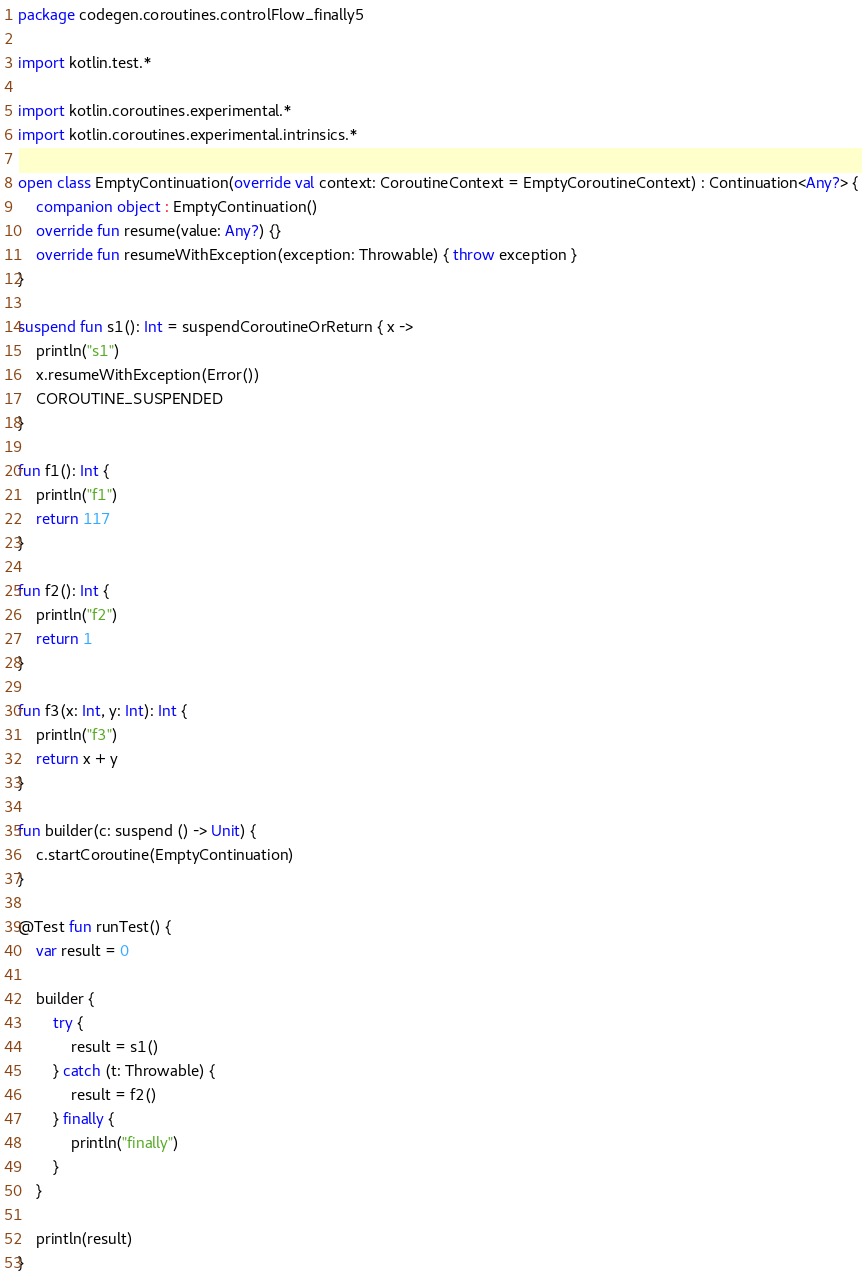<code> <loc_0><loc_0><loc_500><loc_500><_Kotlin_>package codegen.coroutines.controlFlow_finally5

import kotlin.test.*

import kotlin.coroutines.experimental.*
import kotlin.coroutines.experimental.intrinsics.*

open class EmptyContinuation(override val context: CoroutineContext = EmptyCoroutineContext) : Continuation<Any?> {
    companion object : EmptyContinuation()
    override fun resume(value: Any?) {}
    override fun resumeWithException(exception: Throwable) { throw exception }
}

suspend fun s1(): Int = suspendCoroutineOrReturn { x ->
    println("s1")
    x.resumeWithException(Error())
    COROUTINE_SUSPENDED
}

fun f1(): Int {
    println("f1")
    return 117
}

fun f2(): Int {
    println("f2")
    return 1
}

fun f3(x: Int, y: Int): Int {
    println("f3")
    return x + y
}

fun builder(c: suspend () -> Unit) {
    c.startCoroutine(EmptyContinuation)
}

@Test fun runTest() {
    var result = 0

    builder {
        try {
            result = s1()
        } catch (t: Throwable) {
            result = f2()
        } finally {
            println("finally")
        }
    }

    println(result)
}</code> 